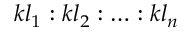<formula> <loc_0><loc_0><loc_500><loc_500>k l _ { 1 } \colon k l _ { 2 } \colon \dots \colon k l _ { n }</formula> 